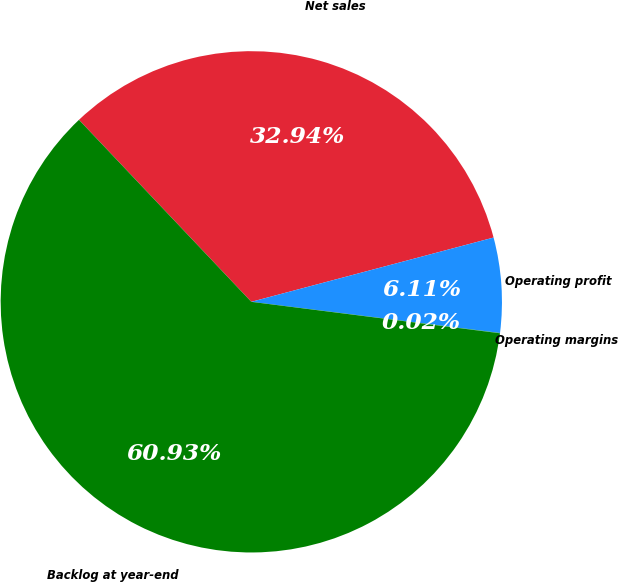<chart> <loc_0><loc_0><loc_500><loc_500><pie_chart><fcel>Net sales<fcel>Operating profit<fcel>Operating margins<fcel>Backlog at year-end<nl><fcel>32.94%<fcel>6.11%<fcel>0.02%<fcel>60.93%<nl></chart> 